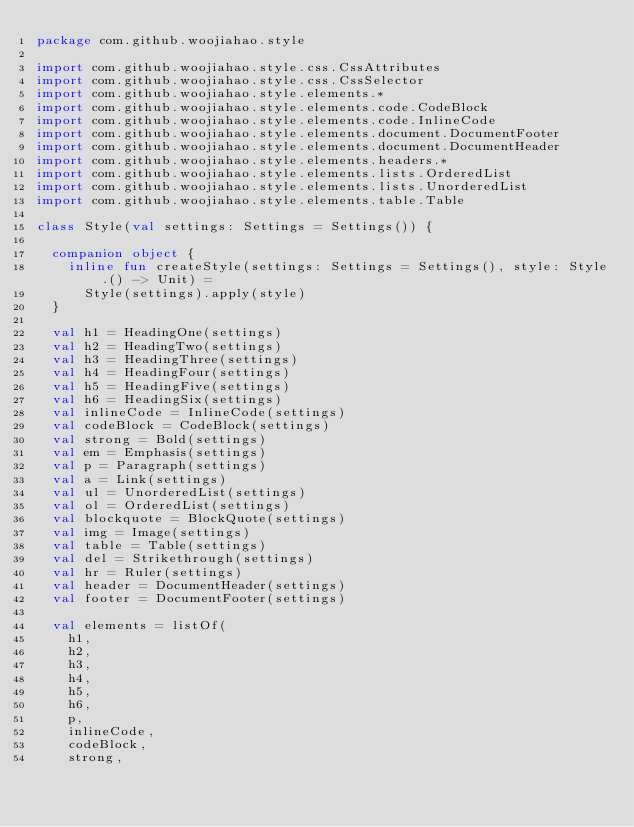Convert code to text. <code><loc_0><loc_0><loc_500><loc_500><_Kotlin_>package com.github.woojiahao.style

import com.github.woojiahao.style.css.CssAttributes
import com.github.woojiahao.style.css.CssSelector
import com.github.woojiahao.style.elements.*
import com.github.woojiahao.style.elements.code.CodeBlock
import com.github.woojiahao.style.elements.code.InlineCode
import com.github.woojiahao.style.elements.document.DocumentFooter
import com.github.woojiahao.style.elements.document.DocumentHeader
import com.github.woojiahao.style.elements.headers.*
import com.github.woojiahao.style.elements.lists.OrderedList
import com.github.woojiahao.style.elements.lists.UnorderedList
import com.github.woojiahao.style.elements.table.Table

class Style(val settings: Settings = Settings()) {

  companion object {
    inline fun createStyle(settings: Settings = Settings(), style: Style.() -> Unit) =
      Style(settings).apply(style)
  }

  val h1 = HeadingOne(settings)
  val h2 = HeadingTwo(settings)
  val h3 = HeadingThree(settings)
  val h4 = HeadingFour(settings)
  val h5 = HeadingFive(settings)
  val h6 = HeadingSix(settings)
  val inlineCode = InlineCode(settings)
  val codeBlock = CodeBlock(settings)
  val strong = Bold(settings)
  val em = Emphasis(settings)
  val p = Paragraph(settings)
  val a = Link(settings)
  val ul = UnorderedList(settings)
  val ol = OrderedList(settings)
  val blockquote = BlockQuote(settings)
  val img = Image(settings)
  val table = Table(settings)
  val del = Strikethrough(settings)
  val hr = Ruler(settings)
  val header = DocumentHeader(settings)
  val footer = DocumentFooter(settings)

  val elements = listOf(
    h1,
    h2,
    h3,
    h4,
    h5,
    h6,
    p,
    inlineCode,
    codeBlock,
    strong,</code> 